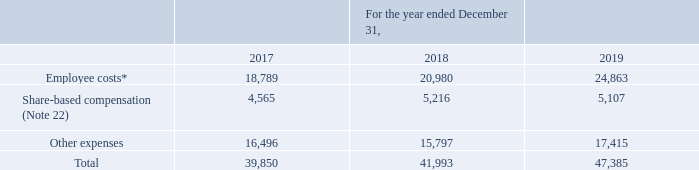GasLog Ltd. and its Subsidiaries
Notes to the consolidated financial statements (Continued)
For the years ended December 31, 2017, 2018 and 2019
(All amounts expressed in thousands of U.S. Dollars, except share and per share data)
17. General and Administrative Expenses
An analysis of general and administrative expenses is as follows:
* Employee costs include restructuring costs of $3,975 pursuant to management’s decision to relocate more of its employees including several members of senior management to the Piraeus, Greece office.
In which year was the general and administrative expenses recorded for? 2017, 2018, 2019. What was the cost of restructuring?
Answer scale should be: thousand. $3,975. Where does the management intend to relocate its employees? Piraeus, greece office. Which year has the highest share-based compensation? 5,216 > 5,107 > 4,565
Answer: 2018. What was the change in other expenses from 2018 to 2019?
Answer scale should be: thousand. 17,415 - 15,797 
Answer: 1618. What was the percentage change in employee costs from 2017 to 2018?
Answer scale should be: percent. (20,980 - 18,789)/18,789 
Answer: 11.66. 